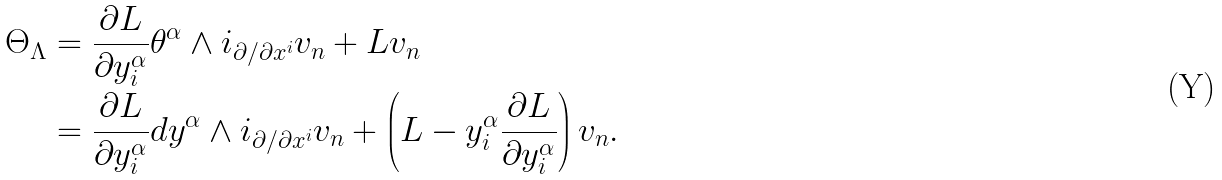Convert formula to latex. <formula><loc_0><loc_0><loc_500><loc_500>\Theta _ { \Lambda } & = \frac { \partial L } { \partial y _ { i } ^ { \alpha } } \theta ^ { \alpha } \wedge i _ { \partial / \partial x ^ { i } } v _ { n } + L v _ { n } \\ & = \frac { \partial L } { \partial y _ { i } ^ { \alpha } } d y ^ { \alpha } \wedge i _ { \partial / \partial x ^ { i } } v _ { n } + \left ( L - y _ { i } ^ { \alpha } \frac { \partial L } { \partial y _ { i } ^ { \alpha } } \right ) v _ { n } .</formula> 